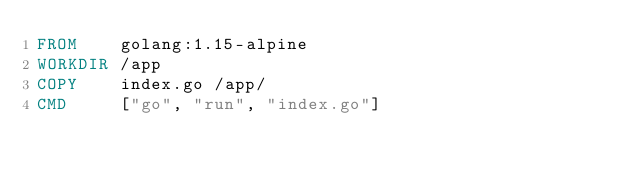Convert code to text. <code><loc_0><loc_0><loc_500><loc_500><_Dockerfile_>FROM    golang:1.15-alpine
WORKDIR /app
COPY    index.go /app/
CMD     ["go", "run", "index.go"]
</code> 